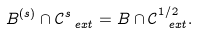Convert formula to latex. <formula><loc_0><loc_0><loc_500><loc_500>B ^ { ( s ) } \cap \mathcal { C } _ { \ e x t } ^ { s } = B \cap \mathcal { C } _ { \ e x t } ^ { 1 / 2 } .</formula> 